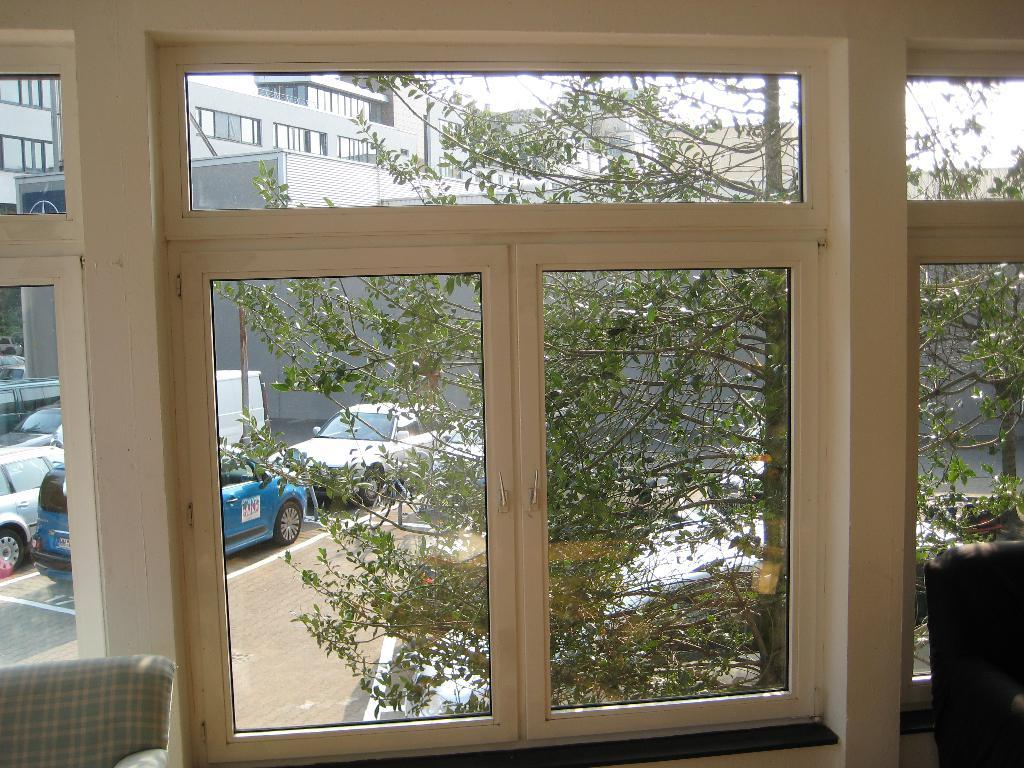What type of structure is present in the image? There is a glass window in the image. What can be seen in the background of the image? There are trees, which are green, and a building, which is gray, in the background of the image. What else is visible in the image? There are vehicles visible in the image. What is the color of the sky in the image? The sky is visible in the image, and it is white. Can you tell me how many lawyers are present in the image? There are no lawyers present in the image. What shape does the end of the building have in the image? The provided facts do not mention the shape of the building's end, and there is no indication of a circle or any other shape in the image. 